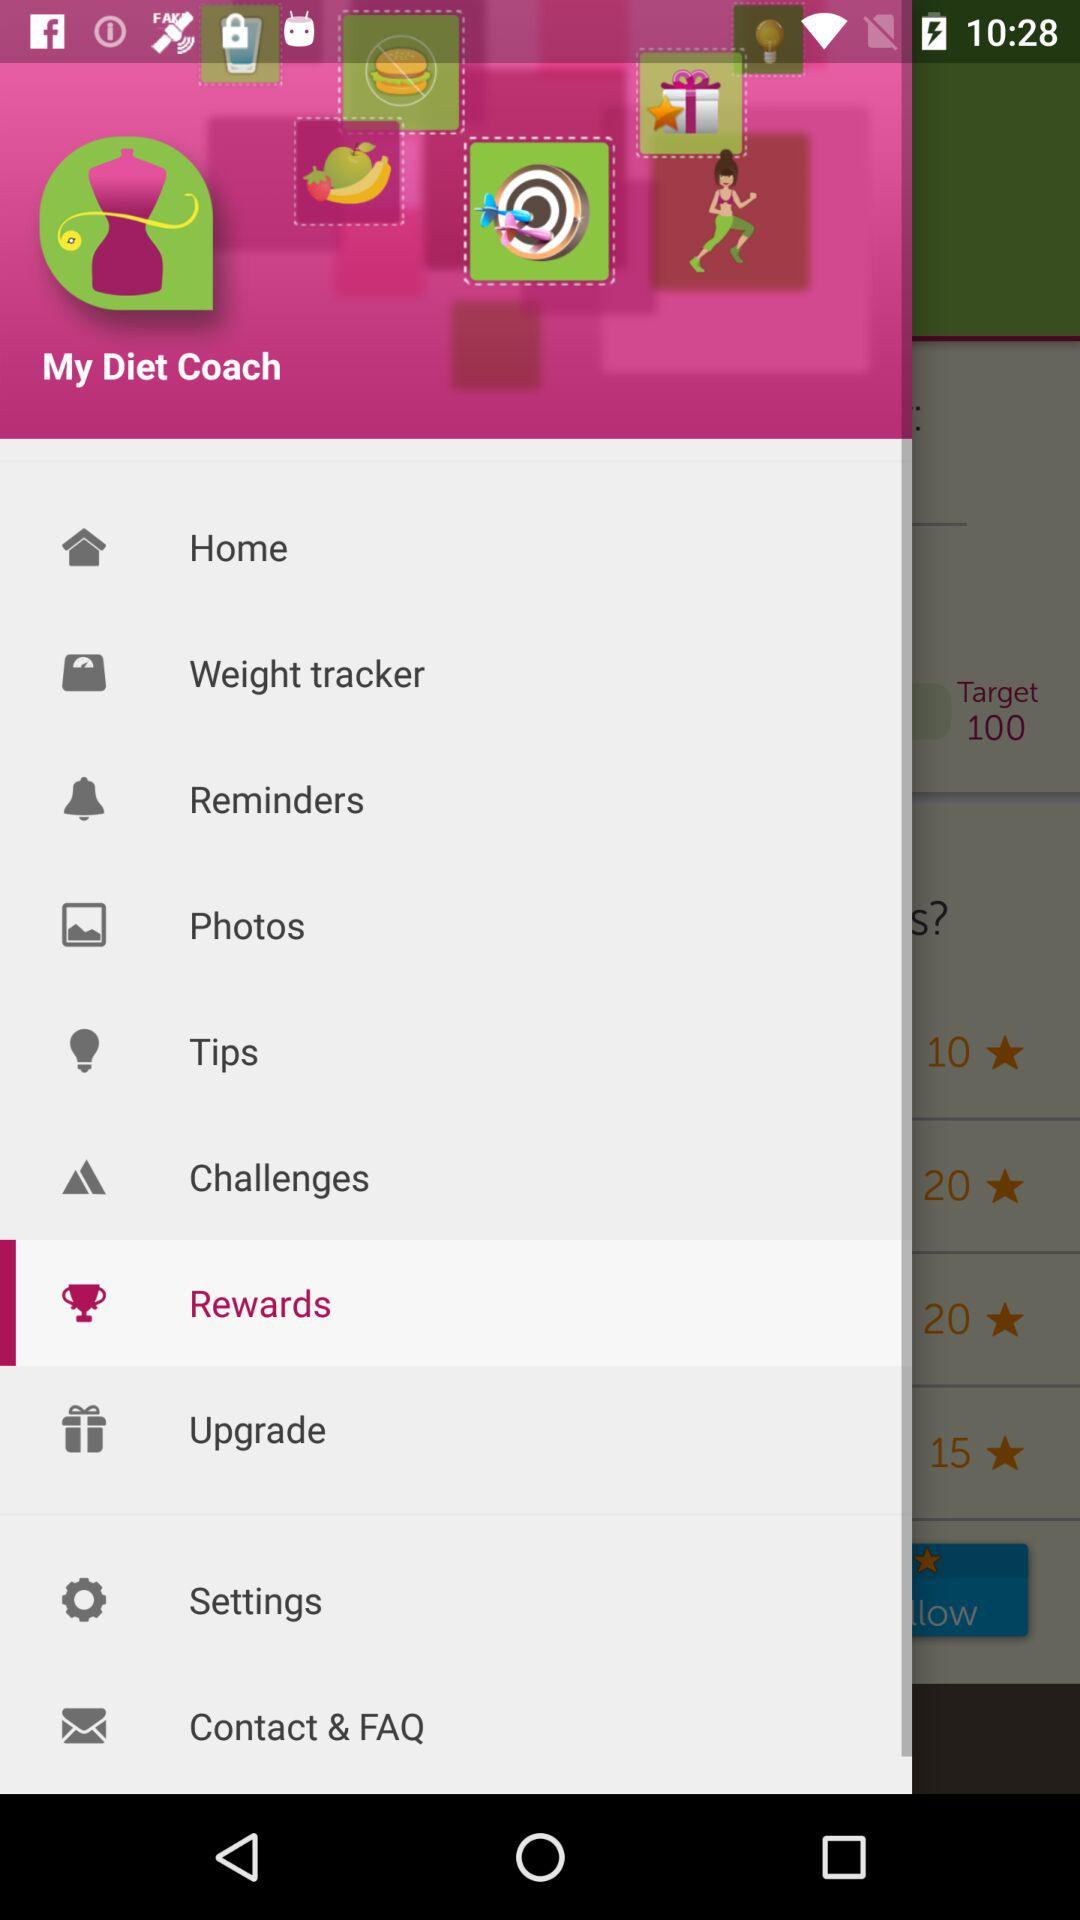What is the name of the application? The name of the application is "My Diet Coach". 